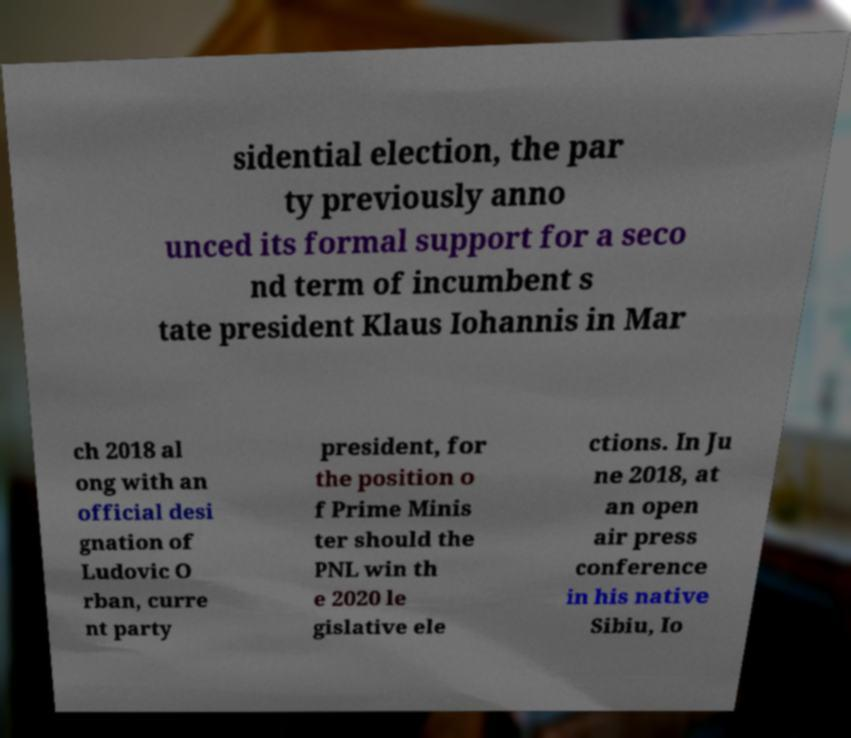Could you assist in decoding the text presented in this image and type it out clearly? sidential election, the par ty previously anno unced its formal support for a seco nd term of incumbent s tate president Klaus Iohannis in Mar ch 2018 al ong with an official desi gnation of Ludovic O rban, curre nt party president, for the position o f Prime Minis ter should the PNL win th e 2020 le gislative ele ctions. In Ju ne 2018, at an open air press conference in his native Sibiu, Io 